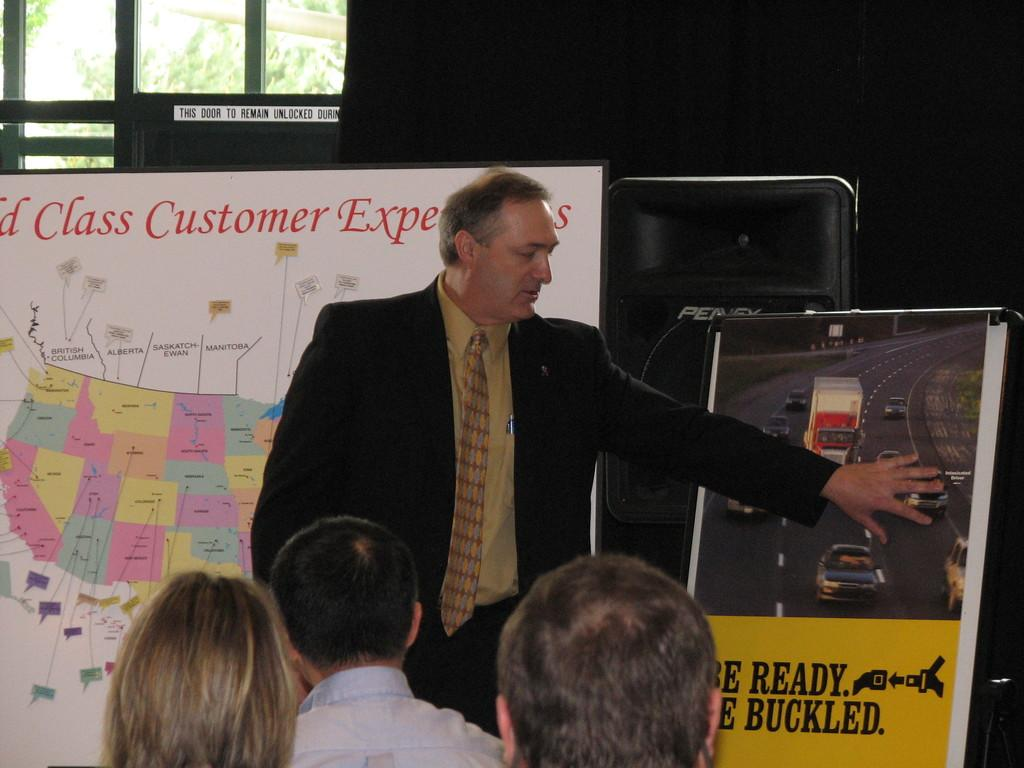How many people are visible in the image? There are many people sitting in the image. Are there any people standing in the image? Yes, one person is standing in the image. What are the people wearing? The people are wearing clothes. What type of image is this? The image is a poster. What can be seen through the window in the poster? Trees are visible through the window. What type of crate is being used to store the substance in the image? There is no crate or substance present in the image. 